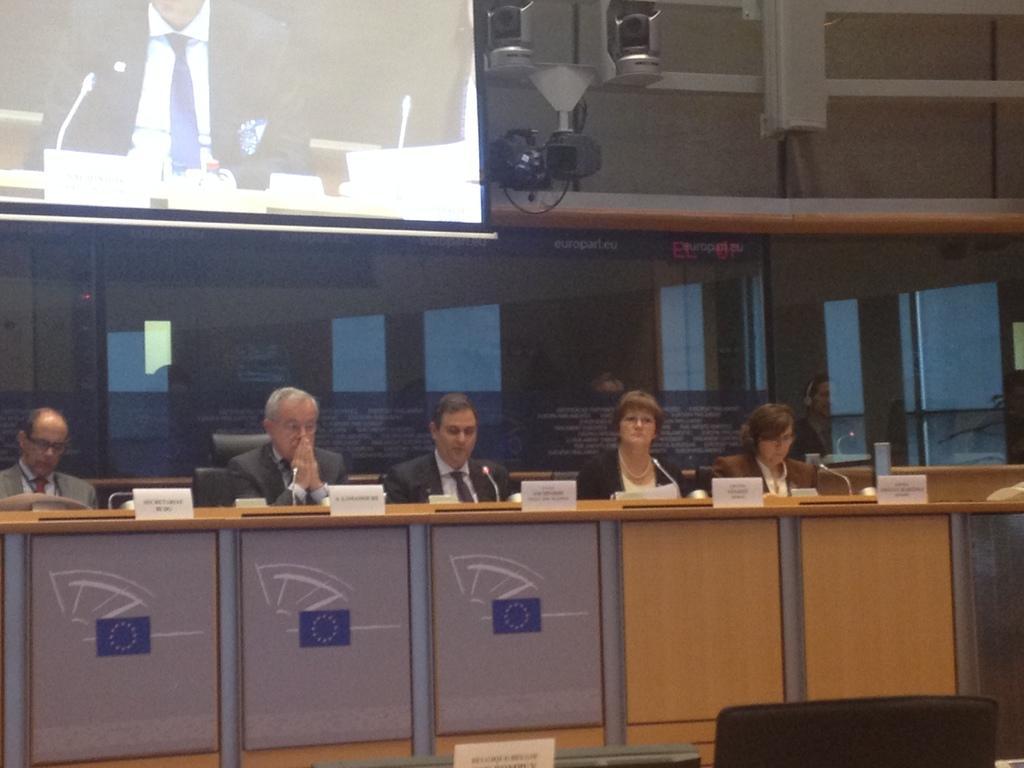In one or two sentences, can you explain what this image depicts? This image is taken indoors. At the bottom of the image there is an empty chair. In the middle of the image there is a table with a few things on it and four men and a woman are sitting on the chairs. In the background there is a wall with windows. At the top of the image there is a chandelier, a speaker box and a projector screen. 